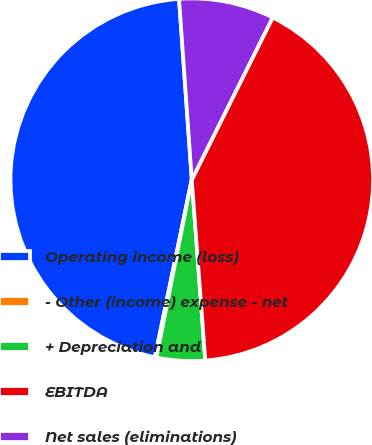Convert chart. <chart><loc_0><loc_0><loc_500><loc_500><pie_chart><fcel>Operating income (loss)<fcel>- Other (income) expense - net<fcel>+ Depreciation and<fcel>EBITDA<fcel>Net sales (eliminations)<nl><fcel>45.62%<fcel>0.14%<fcel>4.31%<fcel>41.45%<fcel>8.48%<nl></chart> 